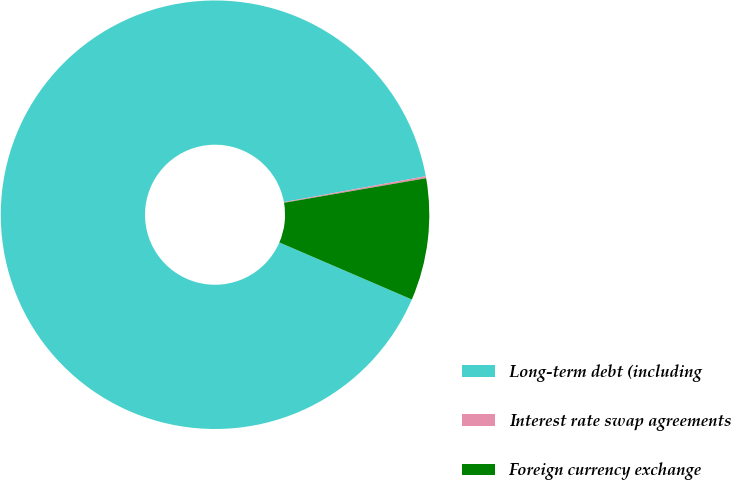Convert chart. <chart><loc_0><loc_0><loc_500><loc_500><pie_chart><fcel>Long-term debt (including<fcel>Interest rate swap agreements<fcel>Foreign currency exchange<nl><fcel>90.66%<fcel>0.15%<fcel>9.2%<nl></chart> 